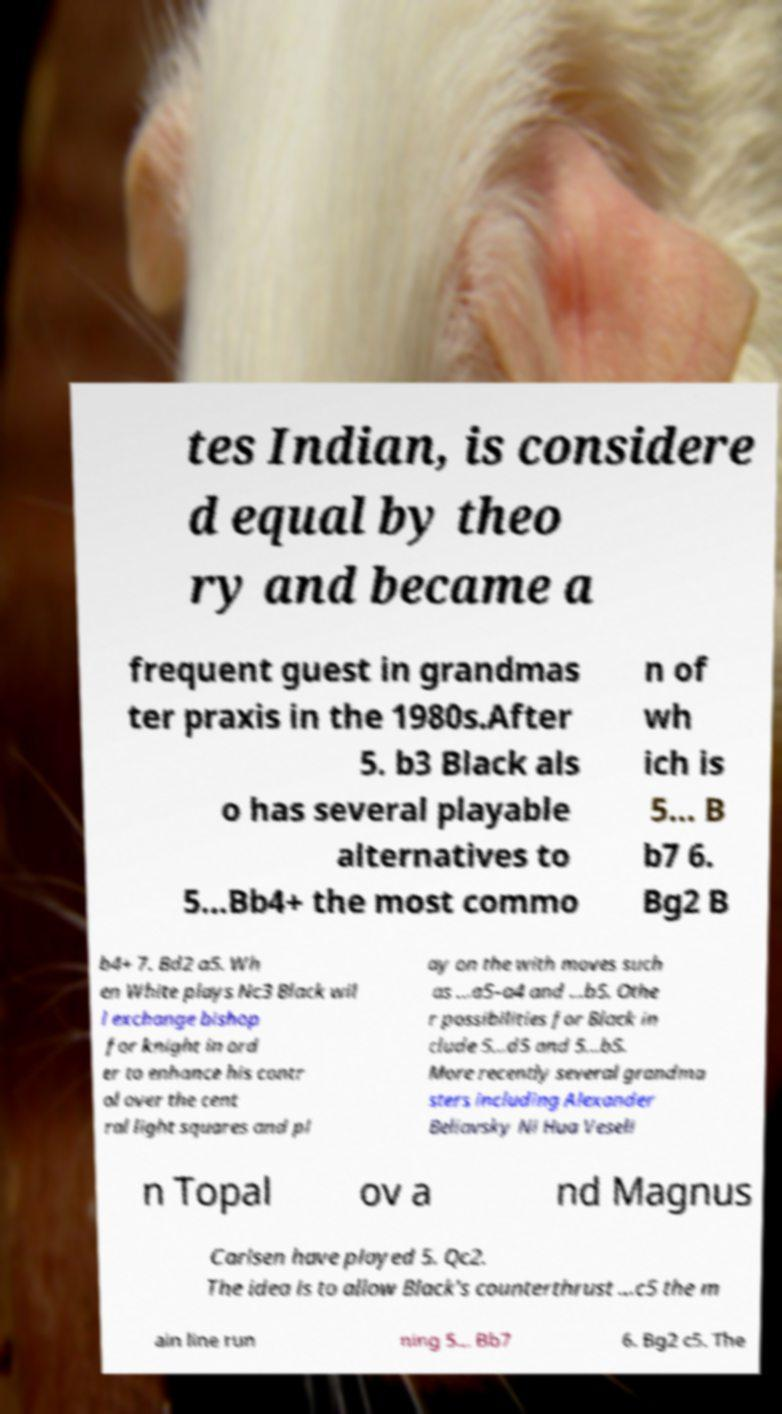Could you assist in decoding the text presented in this image and type it out clearly? tes Indian, is considere d equal by theo ry and became a frequent guest in grandmas ter praxis in the 1980s.After 5. b3 Black als o has several playable alternatives to 5...Bb4+ the most commo n of wh ich is 5... B b7 6. Bg2 B b4+ 7. Bd2 a5. Wh en White plays Nc3 Black wil l exchange bishop for knight in ord er to enhance his contr ol over the cent ral light squares and pl ay on the with moves such as ...a5–a4 and ...b5. Othe r possibilities for Black in clude 5...d5 and 5...b5. More recently several grandma sters including Alexander Beliavsky Ni Hua Veseli n Topal ov a nd Magnus Carlsen have played 5. Qc2. The idea is to allow Black's counterthrust ...c5 the m ain line run ning 5... Bb7 6. Bg2 c5. The 